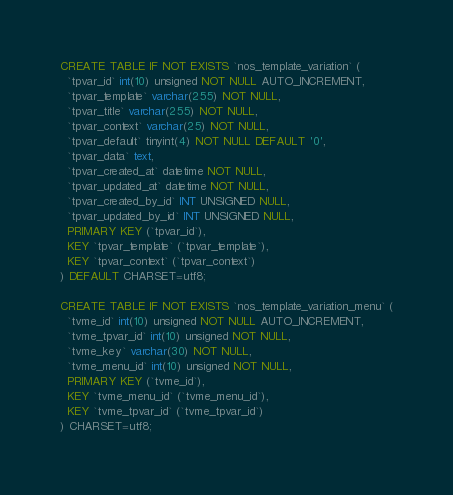<code> <loc_0><loc_0><loc_500><loc_500><_SQL_>CREATE TABLE IF NOT EXISTS `nos_template_variation` (
  `tpvar_id` int(10) unsigned NOT NULL AUTO_INCREMENT,
  `tpvar_template` varchar(255) NOT NULL,
  `tpvar_title` varchar(255) NOT NULL,
  `tpvar_context` varchar(25) NOT NULL,
  `tpvar_default` tinyint(4) NOT NULL DEFAULT '0',
  `tpvar_data` text,
  `tpvar_created_at` datetime NOT NULL,
  `tpvar_updated_at` datetime NOT NULL,
  `tpvar_created_by_id` INT UNSIGNED NULL,
  `tpvar_updated_by_id` INT UNSIGNED NULL,
  PRIMARY KEY (`tpvar_id`),
  KEY `tpvar_template` (`tpvar_template`),
  KEY `tpvar_context` (`tpvar_context`)
) DEFAULT CHARSET=utf8;

CREATE TABLE IF NOT EXISTS `nos_template_variation_menu` (
  `tvme_id` int(10) unsigned NOT NULL AUTO_INCREMENT,
  `tvme_tpvar_id` int(10) unsigned NOT NULL,
  `tvme_key` varchar(30) NOT NULL,
  `tvme_menu_id` int(10) unsigned NOT NULL,
  PRIMARY KEY (`tvme_id`),
  KEY `tvme_menu_id` (`tvme_menu_id`),
  KEY `tvme_tpvar_id` (`tvme_tpvar_id`)
) CHARSET=utf8;
</code> 